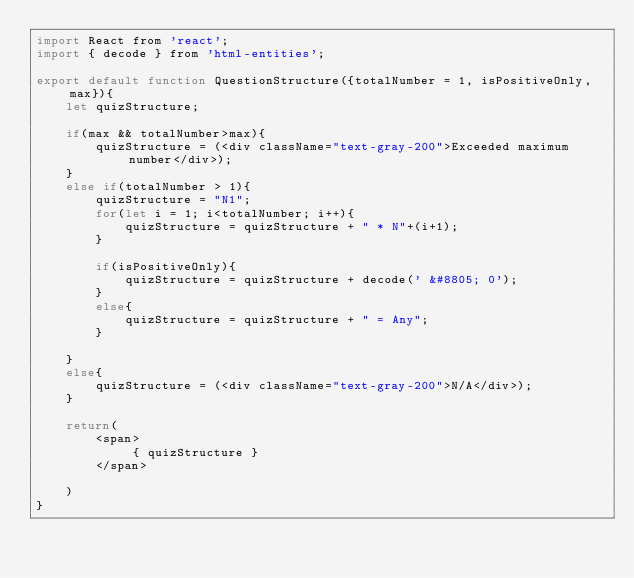<code> <loc_0><loc_0><loc_500><loc_500><_JavaScript_>import React from 'react';
import { decode } from 'html-entities';

export default function QuestionStructure({totalNumber = 1, isPositiveOnly, max}){
    let quizStructure;

    if(max && totalNumber>max){
        quizStructure = (<div className="text-gray-200">Exceeded maximum number</div>);
    }
    else if(totalNumber > 1){
        quizStructure = "N1";
        for(let i = 1; i<totalNumber; i++){
            quizStructure = quizStructure + " * N"+(i+1);
        }

        if(isPositiveOnly){
            quizStructure = quizStructure + decode(' &#8805; 0');
        }
        else{
            quizStructure = quizStructure + " = Any";
        }

    }
    else{
        quizStructure = (<div className="text-gray-200">N/A</div>);
    }

    return(
        <span>
             { quizStructure }
        </span>

    )
}
</code> 